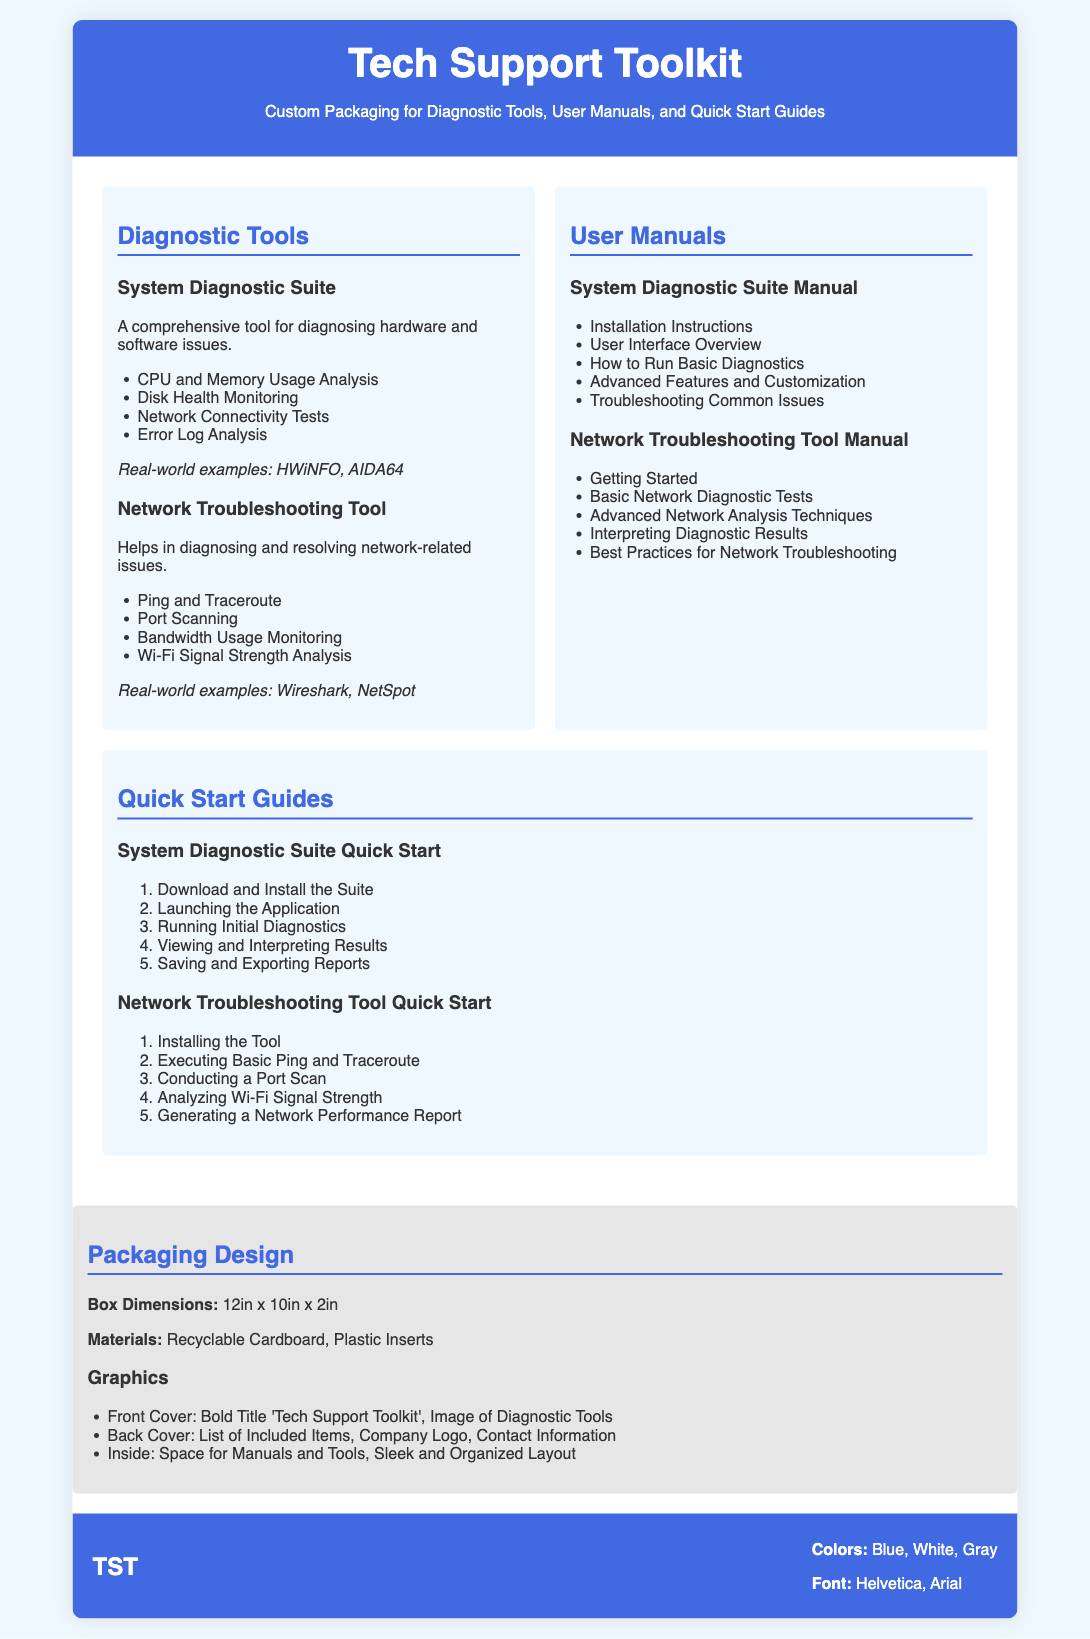What is the title of the packaging document? The title of the packaging document is found in the header section, which provides an overview of the product.
Answer: Tech Support Toolkit What are the dimensions of the packaging box? The box dimensions are specified under the packaging design section as a physical measurement.
Answer: 12in x 10in x 2in Which tool is used for diagnosing hardware and software issues? The diagnostic tools section mentions the tool used for comprehensive diagnostics related to hardware and software problems.
Answer: System Diagnostic Suite What is one feature of the Network Troubleshooting Tool? The content provides a list of features for the Network Troubleshooting Tool within its description.
Answer: Ping and Traceroute How many steps are in the Quick Start Guide for the System Diagnostic Suite? The Quick Start Guide includes an ordered list of steps, which can be counted for the answer.
Answer: 5 What materials are used for the packaging? The packaging design section outlines the materials that are specified for use in creating the packaging.
Answer: Recyclable Cardboard, Plastic Inserts What color is the logo of the product branding? The branding section describes the color scheme associated with the product branding.
Answer: Blue What is the emphasis on in the Inside graphics of the packaging design? The inside graphics description conveys how the contents should be organized or displayed within the packaging.
Answer: Space for Manuals and Tools 